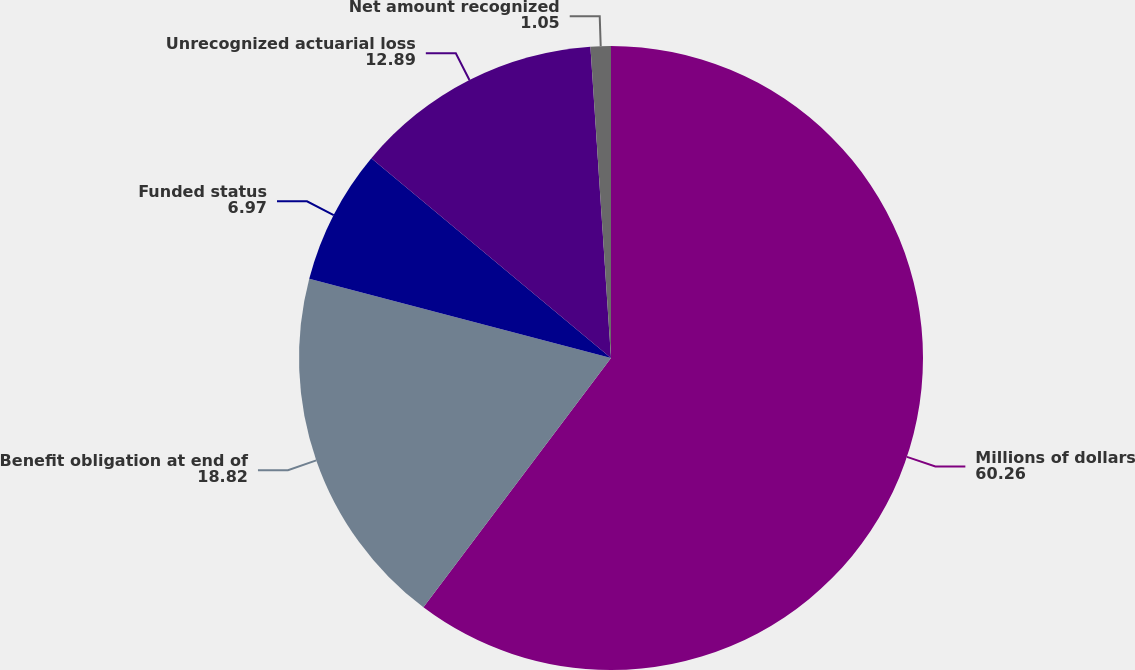Convert chart. <chart><loc_0><loc_0><loc_500><loc_500><pie_chart><fcel>Millions of dollars<fcel>Benefit obligation at end of<fcel>Funded status<fcel>Unrecognized actuarial loss<fcel>Net amount recognized<nl><fcel>60.26%<fcel>18.82%<fcel>6.97%<fcel>12.89%<fcel>1.05%<nl></chart> 